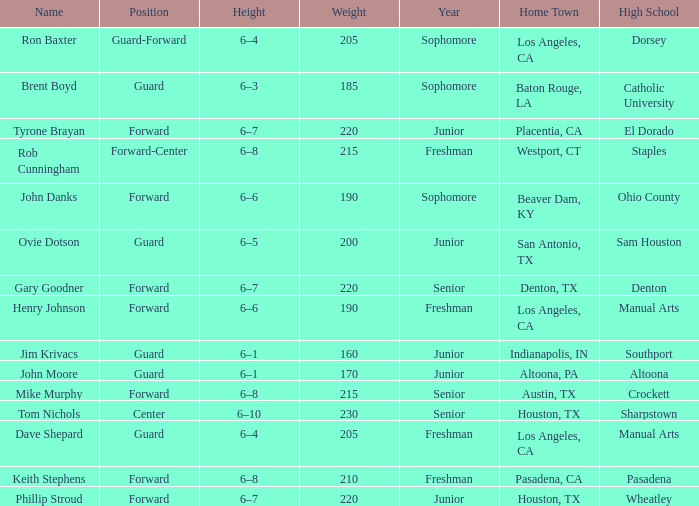What is the Home Town with a Name with rob cunningham? Westport, CT. 